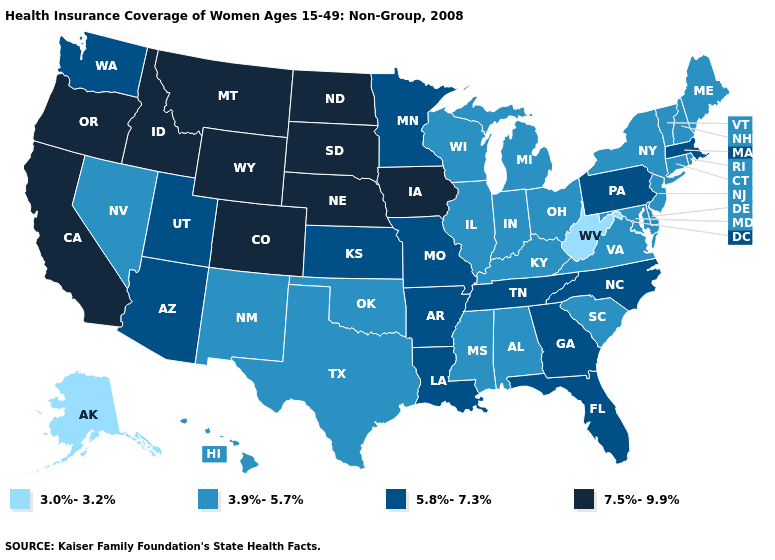Does Mississippi have the highest value in the USA?
Give a very brief answer. No. What is the lowest value in the South?
Quick response, please. 3.0%-3.2%. Among the states that border Arizona , which have the lowest value?
Write a very short answer. Nevada, New Mexico. What is the highest value in states that border Michigan?
Answer briefly. 3.9%-5.7%. Does West Virginia have the lowest value in the USA?
Quick response, please. Yes. Does Pennsylvania have the lowest value in the Northeast?
Quick response, please. No. What is the value of Georgia?
Be succinct. 5.8%-7.3%. Does South Dakota have the highest value in the USA?
Be succinct. Yes. Name the states that have a value in the range 7.5%-9.9%?
Concise answer only. California, Colorado, Idaho, Iowa, Montana, Nebraska, North Dakota, Oregon, South Dakota, Wyoming. Name the states that have a value in the range 7.5%-9.9%?
Short answer required. California, Colorado, Idaho, Iowa, Montana, Nebraska, North Dakota, Oregon, South Dakota, Wyoming. Does New Jersey have a higher value than West Virginia?
Quick response, please. Yes. Among the states that border Pennsylvania , which have the lowest value?
Concise answer only. West Virginia. What is the value of Idaho?
Keep it brief. 7.5%-9.9%. Which states have the highest value in the USA?
Give a very brief answer. California, Colorado, Idaho, Iowa, Montana, Nebraska, North Dakota, Oregon, South Dakota, Wyoming. Does Maine have a higher value than Alaska?
Write a very short answer. Yes. 